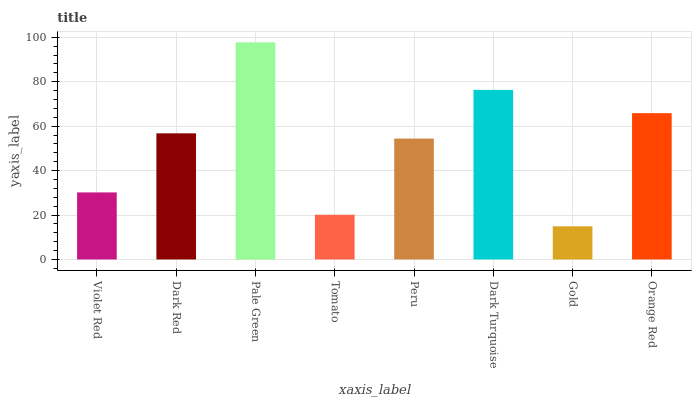Is Gold the minimum?
Answer yes or no. Yes. Is Pale Green the maximum?
Answer yes or no. Yes. Is Dark Red the minimum?
Answer yes or no. No. Is Dark Red the maximum?
Answer yes or no. No. Is Dark Red greater than Violet Red?
Answer yes or no. Yes. Is Violet Red less than Dark Red?
Answer yes or no. Yes. Is Violet Red greater than Dark Red?
Answer yes or no. No. Is Dark Red less than Violet Red?
Answer yes or no. No. Is Dark Red the high median?
Answer yes or no. Yes. Is Peru the low median?
Answer yes or no. Yes. Is Violet Red the high median?
Answer yes or no. No. Is Dark Red the low median?
Answer yes or no. No. 